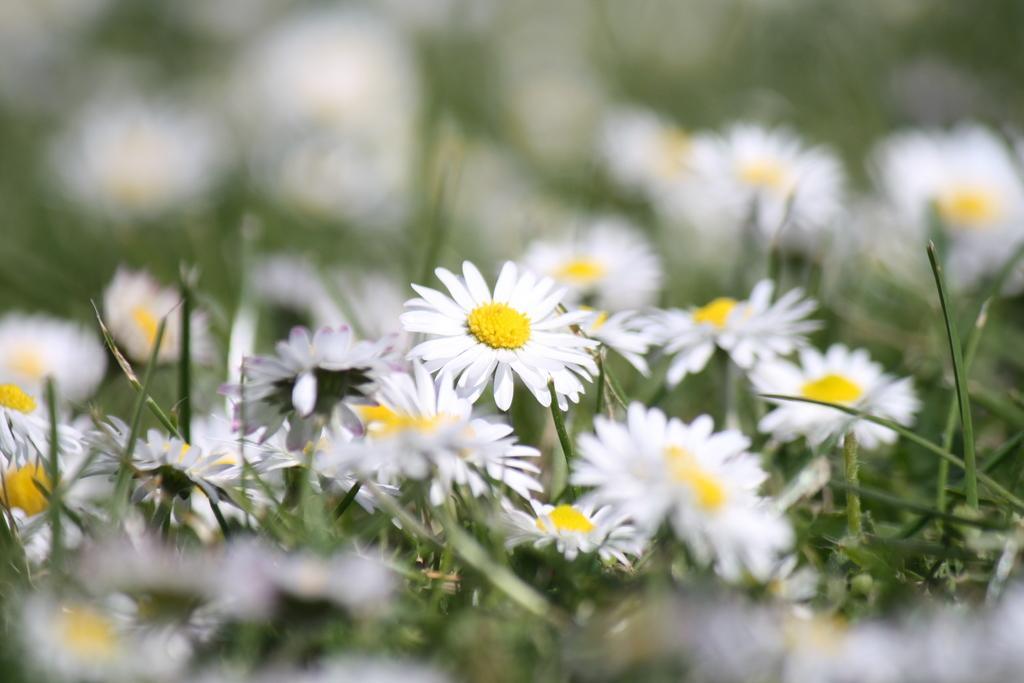In one or two sentences, can you explain what this image depicts? In this image, I can see the plants with flowers. There is a blurred background. 